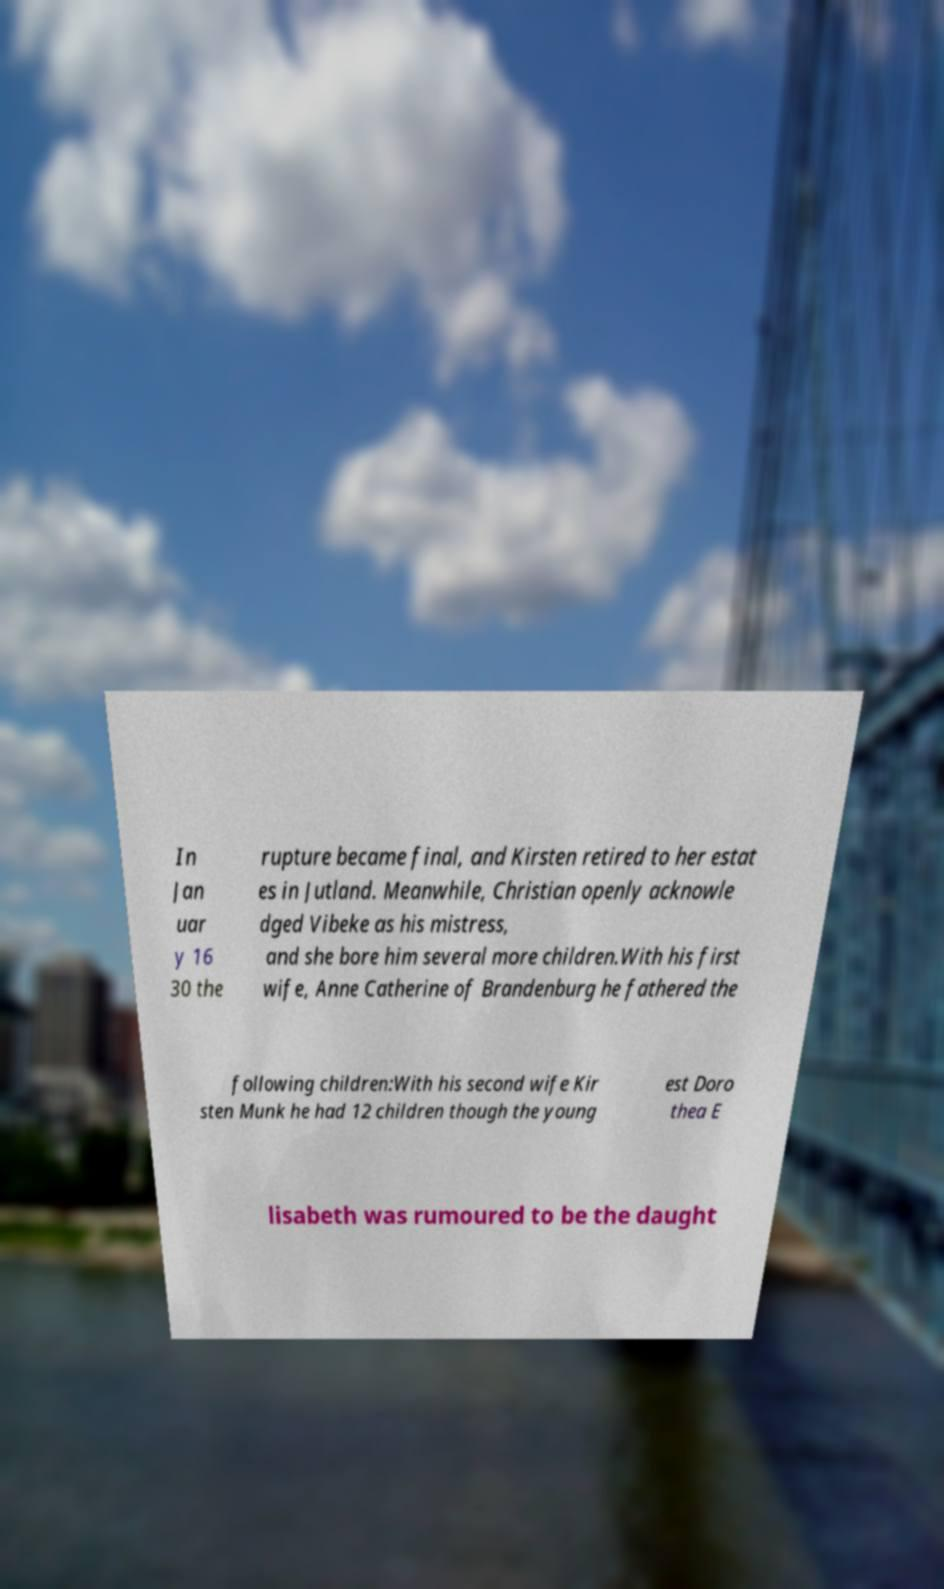Please read and relay the text visible in this image. What does it say? In Jan uar y 16 30 the rupture became final, and Kirsten retired to her estat es in Jutland. Meanwhile, Christian openly acknowle dged Vibeke as his mistress, and she bore him several more children.With his first wife, Anne Catherine of Brandenburg he fathered the following children:With his second wife Kir sten Munk he had 12 children though the young est Doro thea E lisabeth was rumoured to be the daught 